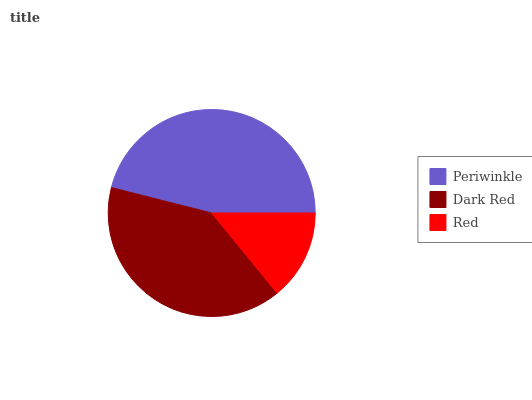Is Red the minimum?
Answer yes or no. Yes. Is Periwinkle the maximum?
Answer yes or no. Yes. Is Dark Red the minimum?
Answer yes or no. No. Is Dark Red the maximum?
Answer yes or no. No. Is Periwinkle greater than Dark Red?
Answer yes or no. Yes. Is Dark Red less than Periwinkle?
Answer yes or no. Yes. Is Dark Red greater than Periwinkle?
Answer yes or no. No. Is Periwinkle less than Dark Red?
Answer yes or no. No. Is Dark Red the high median?
Answer yes or no. Yes. Is Dark Red the low median?
Answer yes or no. Yes. Is Periwinkle the high median?
Answer yes or no. No. Is Red the low median?
Answer yes or no. No. 